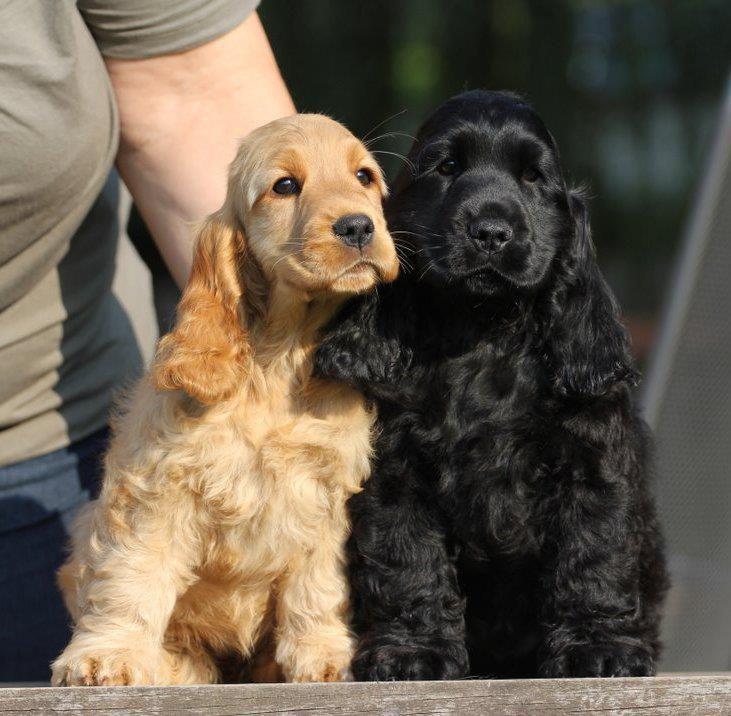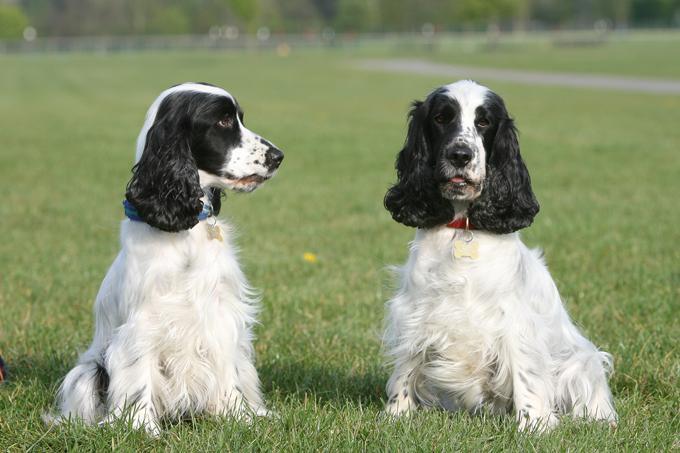The first image is the image on the left, the second image is the image on the right. Considering the images on both sides, is "There are equal amount of dogs on the left image as the right image." valid? Answer yes or no. Yes. The first image is the image on the left, the second image is the image on the right. Given the left and right images, does the statement "There are at least three dogs in the right image." hold true? Answer yes or no. No. 